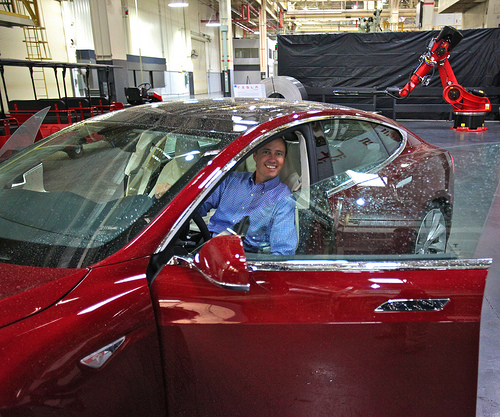<image>
Can you confirm if the man is in the car? Yes. The man is contained within or inside the car, showing a containment relationship. Is the man next to the car? No. The man is not positioned next to the car. They are located in different areas of the scene. 